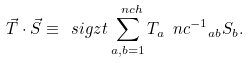Convert formula to latex. <formula><loc_0><loc_0><loc_500><loc_500>\vec { T } \cdot \vec { S } \equiv \ s i g z t \sum _ { a , b = 1 } ^ { \ n c h } T _ { a } { \ n c ^ { - 1 } } _ { a b } S _ { b } .</formula> 